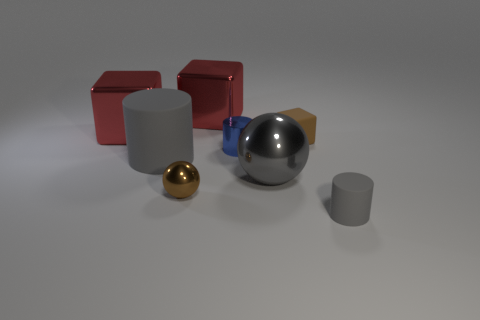Add 1 large red metal things. How many objects exist? 9 Subtract all spheres. How many objects are left? 6 Subtract 0 cyan cylinders. How many objects are left? 8 Subtract all brown cubes. Subtract all shiny cylinders. How many objects are left? 6 Add 1 cylinders. How many cylinders are left? 4 Add 4 gray things. How many gray things exist? 7 